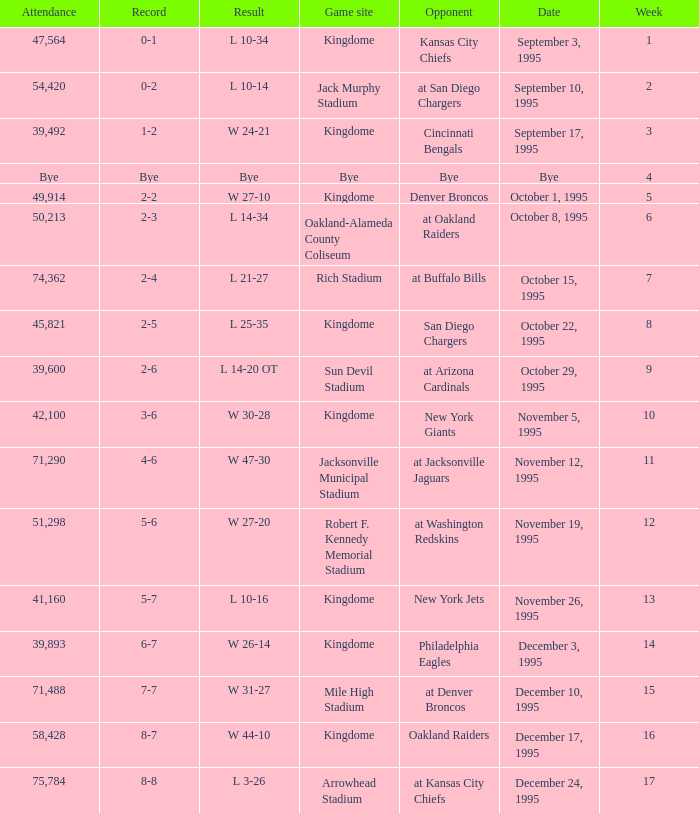Who was the opponent when the Seattle Seahawks had a record of 8-7? Oakland Raiders. 